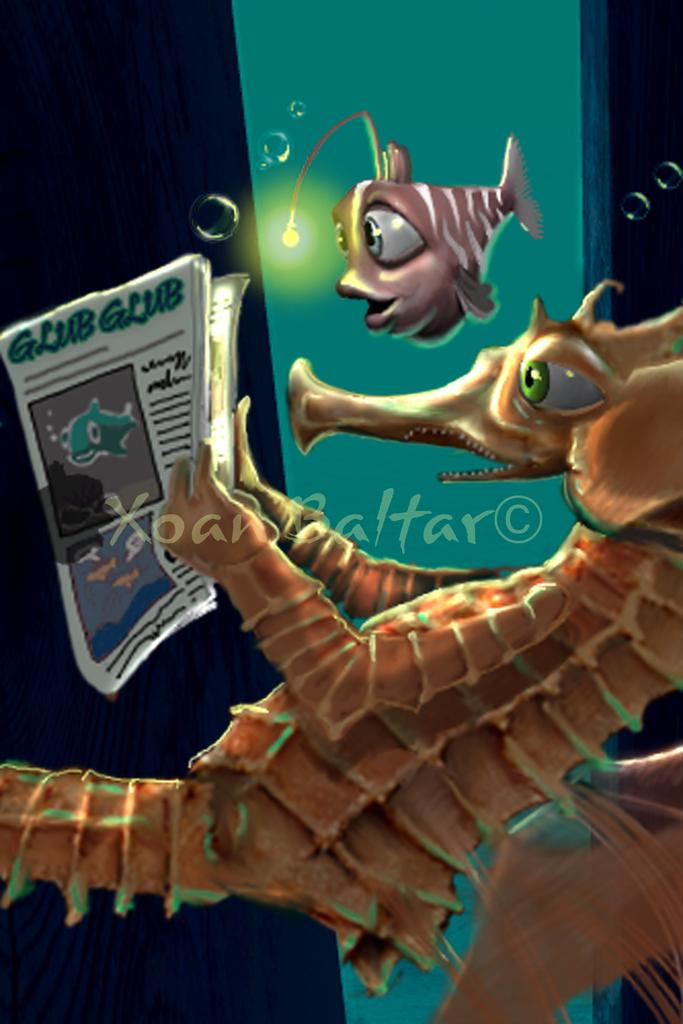What type of media is the image? The image is an animation. What animal is featured in the animation? There is a seahorse in the image. What is the seahorse doing in the animation? The seahorse is reading a newspaper. Are there any other animals present in the image? Yes, there is a fish in the image. What is the name of the company that the seahorse works for in the image? There is no company mentioned or implied in the image, as it is an animation featuring a seahorse reading a newspaper. How does the kitten interact with the seahorse in the image? There is no kitten present in the image; it only features a seahorse and a fish. 